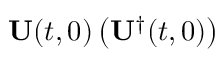Convert formula to latex. <formula><loc_0><loc_0><loc_500><loc_500>U ( t , 0 ) \left ( U ^ { \dagger } ( t , 0 ) \right )</formula> 